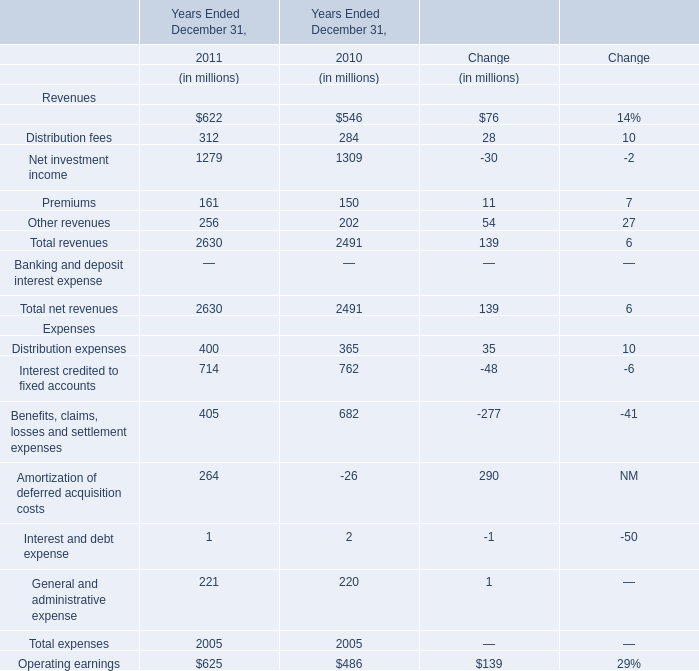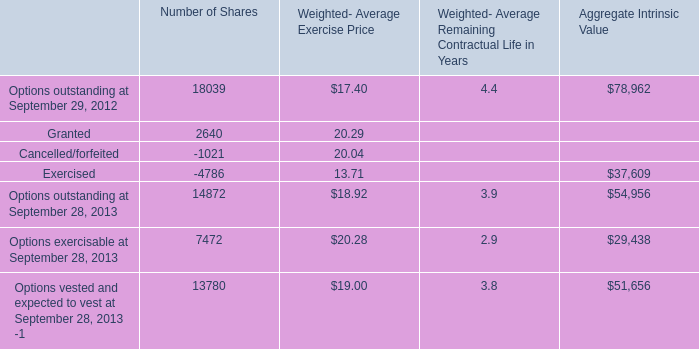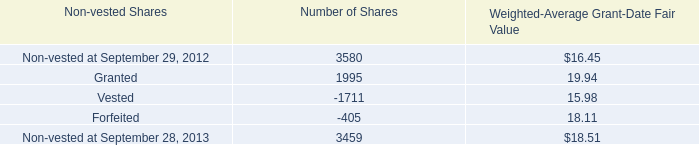What's the average of Options exercisable at September 28, 2013 of Number of Shares, and Vested of Number of Shares ? 
Computations: ((7472.0 + 1711.0) / 2)
Answer: 4591.5. 